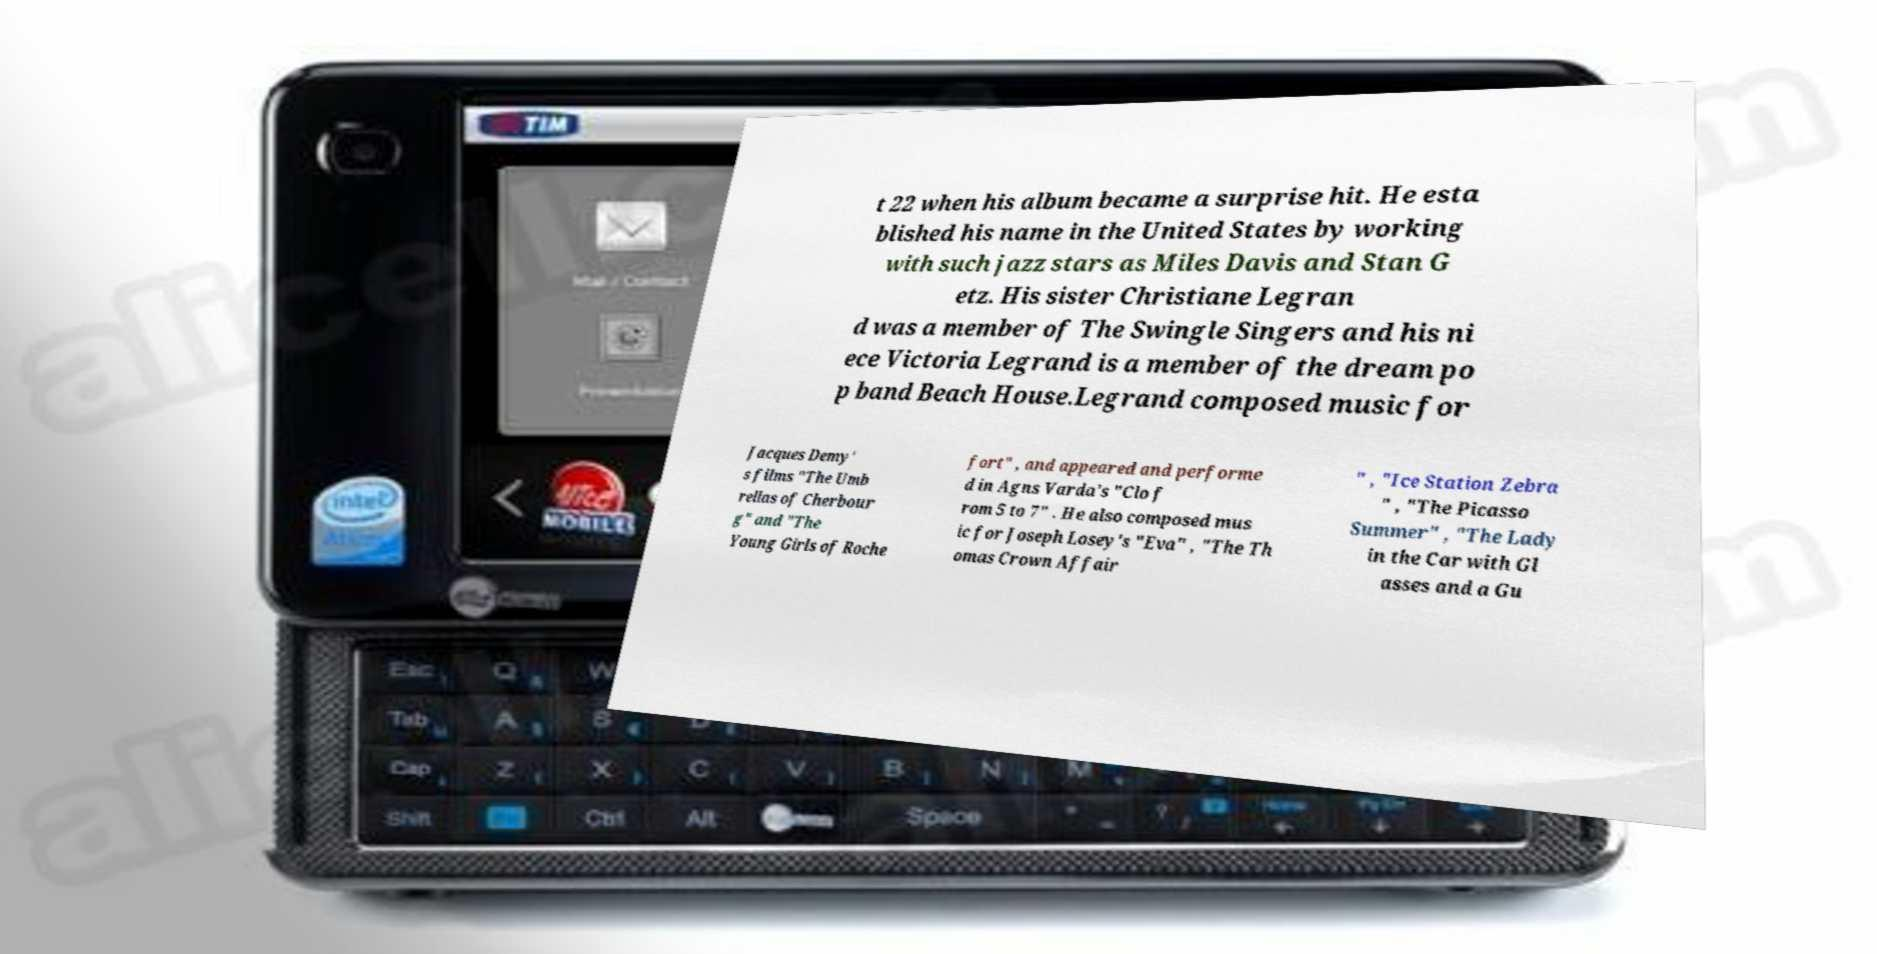Can you read and provide the text displayed in the image?This photo seems to have some interesting text. Can you extract and type it out for me? t 22 when his album became a surprise hit. He esta blished his name in the United States by working with such jazz stars as Miles Davis and Stan G etz. His sister Christiane Legran d was a member of The Swingle Singers and his ni ece Victoria Legrand is a member of the dream po p band Beach House.Legrand composed music for Jacques Demy' s films "The Umb rellas of Cherbour g" and "The Young Girls of Roche fort" , and appeared and performe d in Agns Varda's "Clo f rom 5 to 7" . He also composed mus ic for Joseph Losey's "Eva" , "The Th omas Crown Affair " , "Ice Station Zebra " , "The Picasso Summer" , "The Lady in the Car with Gl asses and a Gu 